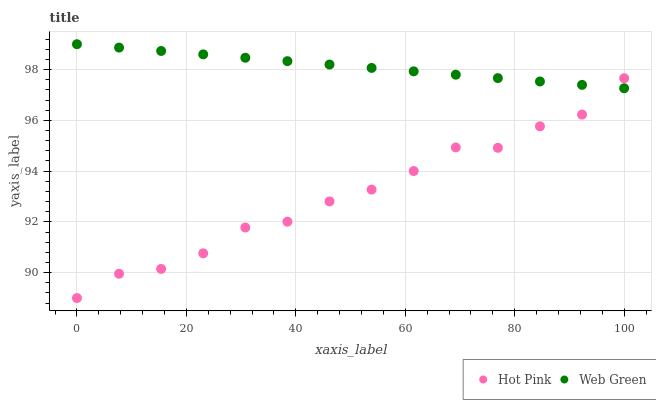Does Hot Pink have the minimum area under the curve?
Answer yes or no. Yes. Does Web Green have the maximum area under the curve?
Answer yes or no. Yes. Does Web Green have the minimum area under the curve?
Answer yes or no. No. Is Web Green the smoothest?
Answer yes or no. Yes. Is Hot Pink the roughest?
Answer yes or no. Yes. Is Web Green the roughest?
Answer yes or no. No. Does Hot Pink have the lowest value?
Answer yes or no. Yes. Does Web Green have the lowest value?
Answer yes or no. No. Does Web Green have the highest value?
Answer yes or no. Yes. Does Hot Pink intersect Web Green?
Answer yes or no. Yes. Is Hot Pink less than Web Green?
Answer yes or no. No. Is Hot Pink greater than Web Green?
Answer yes or no. No. 